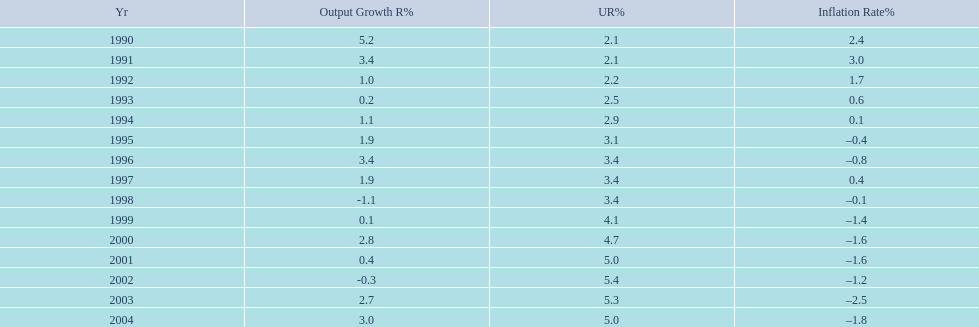In what years, between 1990 and 2004, did japan's unemployment rate reach 5% or higher? 4. 